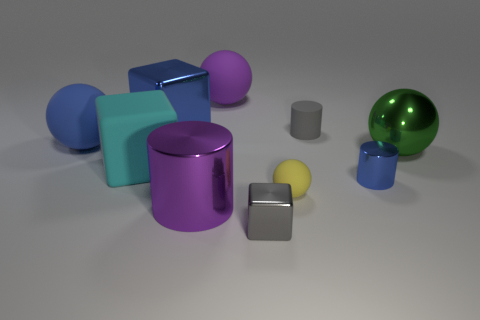Is the color of the small cylinder behind the tiny blue metal cylinder the same as the small rubber ball?
Your response must be concise. No. Do the gray cube and the tiny object that is behind the big blue rubber sphere have the same material?
Ensure brevity in your answer.  No. The purple thing in front of the purple ball has what shape?
Make the answer very short. Cylinder. The blue rubber sphere has what size?
Offer a very short reply. Large. How many other things are there of the same color as the tiny matte cylinder?
Your response must be concise. 1. There is a cylinder that is in front of the big shiny sphere and to the left of the tiny blue cylinder; what is its color?
Your answer should be compact. Purple. How many small shiny things are there?
Ensure brevity in your answer.  2. Is the purple cylinder made of the same material as the yellow ball?
Your answer should be compact. No. There is a big purple object to the left of the big matte object that is behind the blue metal object left of the tiny gray rubber thing; what shape is it?
Make the answer very short. Cylinder. Do the gray thing that is behind the large purple cylinder and the large purple object in front of the big cyan cube have the same material?
Give a very brief answer. No. 